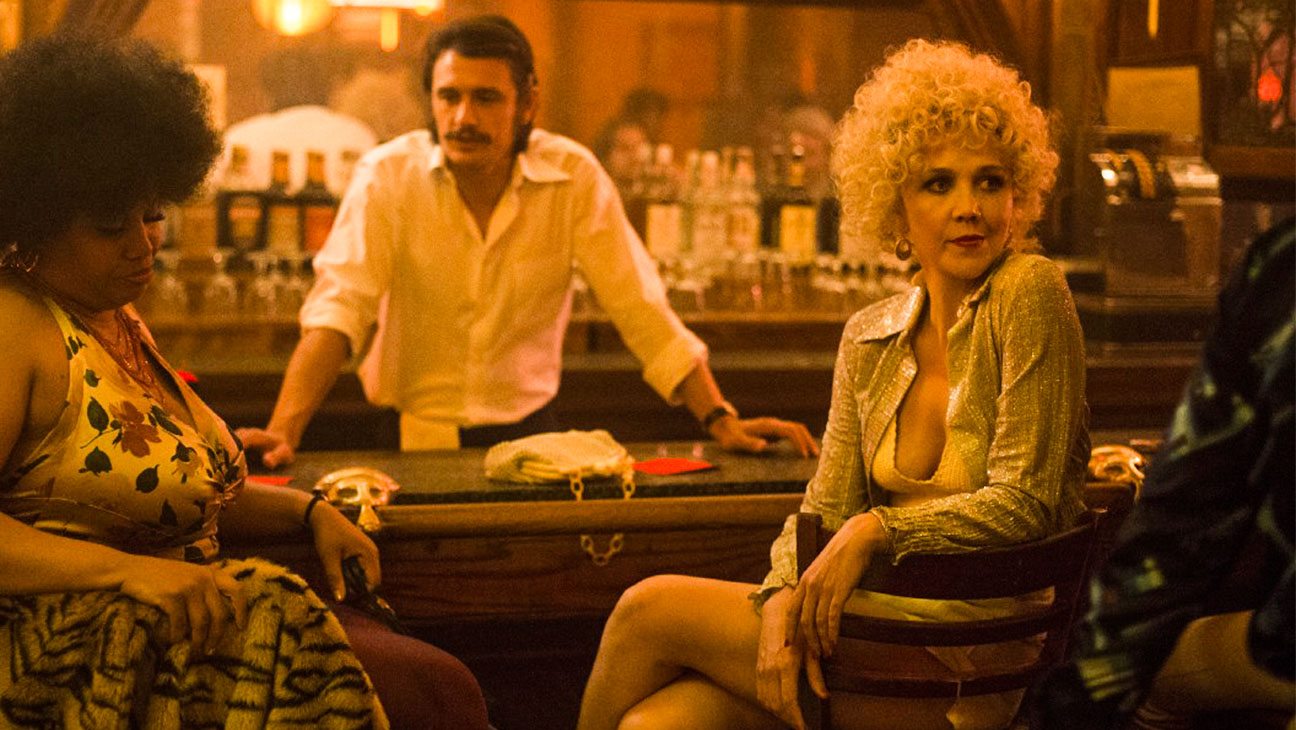Describe the setting of this scene in more detail. The setting is a traditionally styled bar with a rich, moody ambience emphasized by subdued golden lighting and dark wood finishes. The bar itself is lined with various bottles, creating a backdrop filled with glimmers from the reflections of light. Aged posters and elements of vintage decor adorn the walls, contributing to an atmosphere that feels both historical and intimate. The furnishings, including patterned tiles and classic bar stools, reinforce a nostalgic, yet timeless charm, making it an inviting space for nocturnal socializing. 